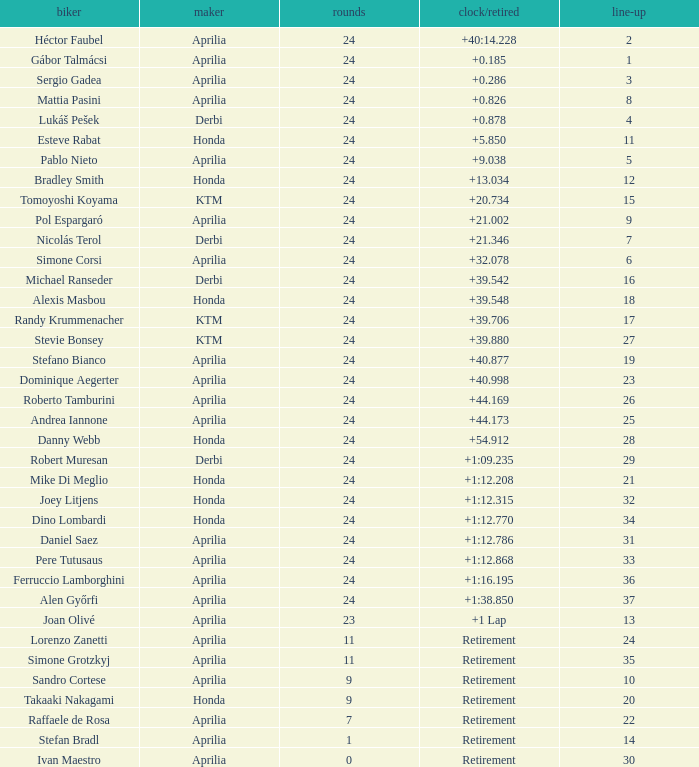What is the time with 10 grids? Retirement. 